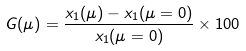<formula> <loc_0><loc_0><loc_500><loc_500>G ( \mu ) = \frac { x _ { 1 } ( \mu ) - x _ { 1 } ( \mu = 0 ) } { x _ { 1 } ( \mu = 0 ) } \times 1 0 0</formula> 